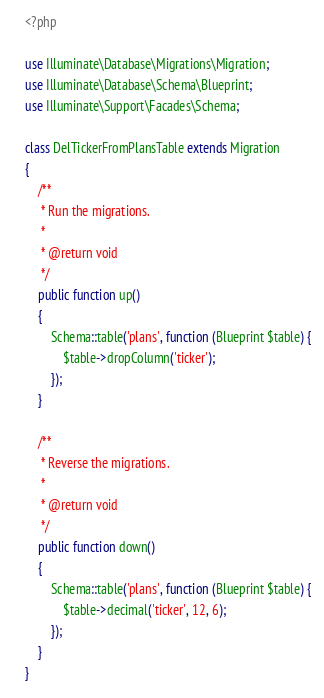<code> <loc_0><loc_0><loc_500><loc_500><_PHP_><?php

use Illuminate\Database\Migrations\Migration;
use Illuminate\Database\Schema\Blueprint;
use Illuminate\Support\Facades\Schema;

class DelTickerFromPlansTable extends Migration
{
    /**
     * Run the migrations.
     *
     * @return void
     */
    public function up()
    {
        Schema::table('plans', function (Blueprint $table) {
            $table->dropColumn('ticker');
        });
    }

    /**
     * Reverse the migrations.
     *
     * @return void
     */
    public function down()
    {
        Schema::table('plans', function (Blueprint $table) {
            $table->decimal('ticker', 12, 6);
        });
    }
}
</code> 